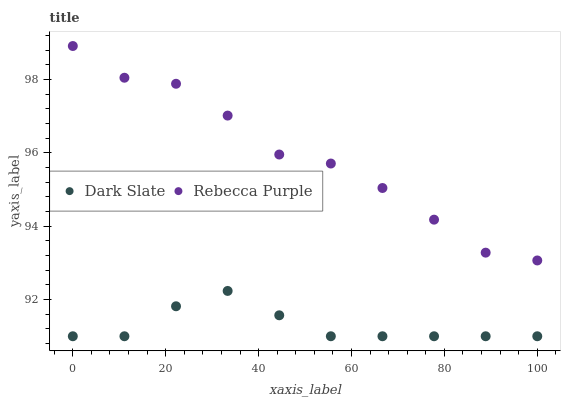Does Dark Slate have the minimum area under the curve?
Answer yes or no. Yes. Does Rebecca Purple have the maximum area under the curve?
Answer yes or no. Yes. Does Rebecca Purple have the minimum area under the curve?
Answer yes or no. No. Is Dark Slate the smoothest?
Answer yes or no. Yes. Is Rebecca Purple the roughest?
Answer yes or no. Yes. Is Rebecca Purple the smoothest?
Answer yes or no. No. Does Dark Slate have the lowest value?
Answer yes or no. Yes. Does Rebecca Purple have the lowest value?
Answer yes or no. No. Does Rebecca Purple have the highest value?
Answer yes or no. Yes. Is Dark Slate less than Rebecca Purple?
Answer yes or no. Yes. Is Rebecca Purple greater than Dark Slate?
Answer yes or no. Yes. Does Dark Slate intersect Rebecca Purple?
Answer yes or no. No. 